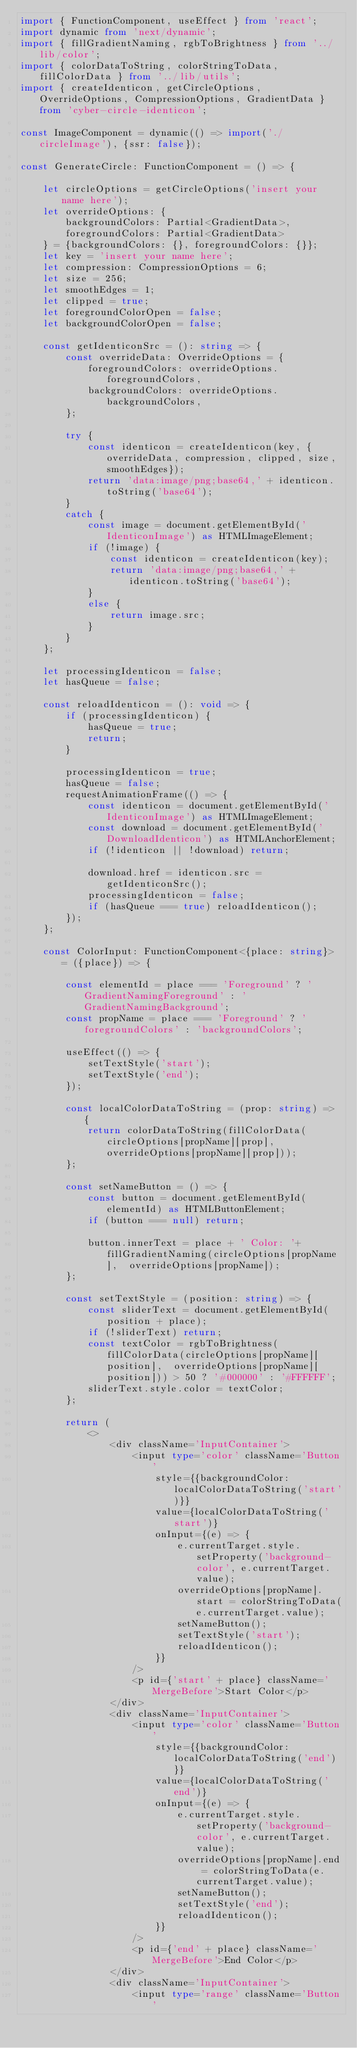<code> <loc_0><loc_0><loc_500><loc_500><_TypeScript_>import { FunctionComponent, useEffect } from 'react';
import dynamic from 'next/dynamic';
import { fillGradientNaming, rgbToBrightness } from '../lib/color';
import { colorDataToString, colorStringToData, fillColorData } from '../lib/utils';
import { createIdenticon, getCircleOptions, OverrideOptions, CompressionOptions, GradientData } from 'cyber-circle-identicon';

const ImageComponent = dynamic(() => import('./circleImage'), {ssr: false});

const GenerateCircle: FunctionComponent = () => {
	
	let circleOptions = getCircleOptions('insert your name here');
	let overrideOptions: {
		backgroundColors: Partial<GradientData>,
		foregroundColors: Partial<GradientData>
	} = {backgroundColors: {}, foregroundColors: {}};
	let key = 'insert your name here';
	let compression: CompressionOptions = 6;
	let size = 256;
	let smoothEdges = 1;
	let clipped = true;
	let foregroundColorOpen = false;
	let backgroundColorOpen = false;

	const getIdenticonSrc = (): string => {
		const overrideData: OverrideOptions = {
			foregroundColors: overrideOptions.foregroundColors,
			backgroundColors: overrideOptions.backgroundColors,
		};

		try {
			const identicon = createIdenticon(key, {overrideData, compression, clipped, size, smoothEdges});
			return 'data:image/png;base64,' + identicon.toString('base64');
		}
		catch {
			const image = document.getElementById('IdenticonImage') as HTMLImageElement;
			if (!image) {
				const identicon = createIdenticon(key);
				return 'data:image/png;base64,' + identicon.toString('base64');
			}
			else {
				return image.src;
			}
		}
	};

	let processingIdenticon = false;
	let hasQueue = false;

	const reloadIdenticon = (): void => {
		if (processingIdenticon) {
			hasQueue = true;
			return;
		}

		processingIdenticon = true;
		hasQueue = false;
		requestAnimationFrame(() => {
			const identicon = document.getElementById('IdenticonImage') as HTMLImageElement;
			const download = document.getElementById('DownloadIdenticon') as HTMLAnchorElement;
			if (!identicon || !download) return;

			download.href = identicon.src = getIdenticonSrc();
			processingIdenticon = false;
			if (hasQueue === true) reloadIdenticon();
		});
	};

	const ColorInput: FunctionComponent<{place: string}> = ({place}) => {

		const elementId = place === 'Foreground' ? 'GradientNamingForeground' : 'GradientNamingBackground';
		const propName = place === 'Foreground' ? 'foregroundColors' : 'backgroundColors';
	
		useEffect(() => {
			setTextStyle('start');
			setTextStyle('end');
		});
	
		const localColorDataToString = (prop: string) => {
			return colorDataToString(fillColorData(circleOptions[propName][prop],  overrideOptions[propName][prop]));
		};
	
		const setNameButton = () => {
			const button = document.getElementById(elementId) as HTMLButtonElement;
			if (button === null) return;
	
			button.innerText = place + ' Color: '+ fillGradientNaming(circleOptions[propName],  overrideOptions[propName]);
		};
	
		const setTextStyle = (position: string) => {
			const sliderText = document.getElementById(position + place);
			if (!sliderText) return;
			const textColor = rgbToBrightness(fillColorData(circleOptions[propName][position],  overrideOptions[propName][position])) > 50 ? '#000000' : '#FFFFFF';
			sliderText.style.color = textColor;
		};
	
		return (
			<>
				<div className='InputContainer'>
					<input type='color' className='Button'
						style={{backgroundColor: localColorDataToString('start')}}
						value={localColorDataToString('start')}
						onInput={(e) => {
							e.currentTarget.style.setProperty('background-color', e.currentTarget.value);
							overrideOptions[propName].start = colorStringToData(e.currentTarget.value);
							setNameButton();
							setTextStyle('start');
							reloadIdenticon();
						}}
					/>
					<p id={'start' + place} className='MergeBefore'>Start Color</p>
				</div>
				<div className='InputContainer'>
					<input type='color' className='Button'
						style={{backgroundColor: localColorDataToString('end')}}
						value={localColorDataToString('end')}
						onInput={(e) => {
							e.currentTarget.style.setProperty('background-color', e.currentTarget.value);
							overrideOptions[propName].end = colorStringToData(e.currentTarget.value);
							setNameButton();
							setTextStyle('end');
							reloadIdenticon();
						}}
					/>
					<p id={'end' + place} className='MergeBefore'>End Color</p>
				</div>
				<div className='InputContainer'>
					<input type='range' className='Button'</code> 